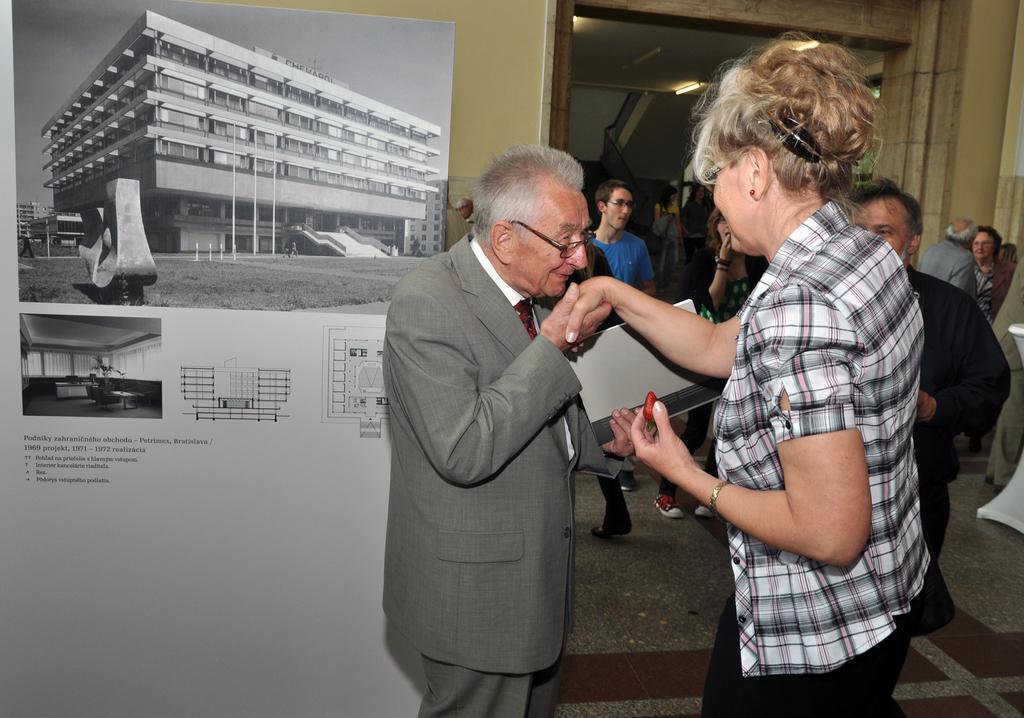Can you describe this image briefly? In the center of the image we can see two persons are standing and a man is holding a laptop. In the background of the image we can see the wall, board, door, lights, roof and a group of people. At the bottom of the image we can see the floor. 